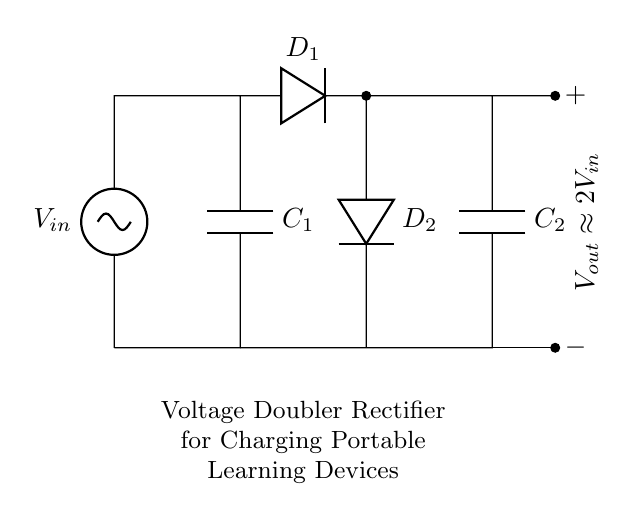What is the input voltage in this circuit? The input voltage, labeled as V_{in}, is the voltage supplied to the circuit. It is shown at the left side of the diagram and is necessary for the operation of the rectifier.
Answer: V_{in} How many capacitors are in this circuit? There are two capacitors, C_1 and C_2, which store charge and are essential for doubling the output voltage in the circuit.
Answer: 2 What does the output voltage approximate? The output voltage is approximately double the input voltage, as indicated in the diagram. This is achieved through the arrangement of the diodes and capacitors.
Answer: 2V_{in} Which component ensures that current flows in only one direction? The diodes, D_1 and D_2, prevent current from flowing backward through the circuit, allowing for proper rectification and charging of the connected devices.
Answer: Diodes How does the circuit double the voltage? The circuit doubles the voltage by utilizing the charging and discharging action of the capacitors in conjunction with the diodes, which allows the capacitors to store and then release voltage, effectively multiplying the input voltage by two.
Answer: By capacitors and diodes What is the purpose of this rectifier circuit? The primary purpose of this voltage doubler rectifier circuit is to efficiently charge portable learning tablets and e-readers by converting the input AC voltage into a higher DC voltage.
Answer: Charge devices 